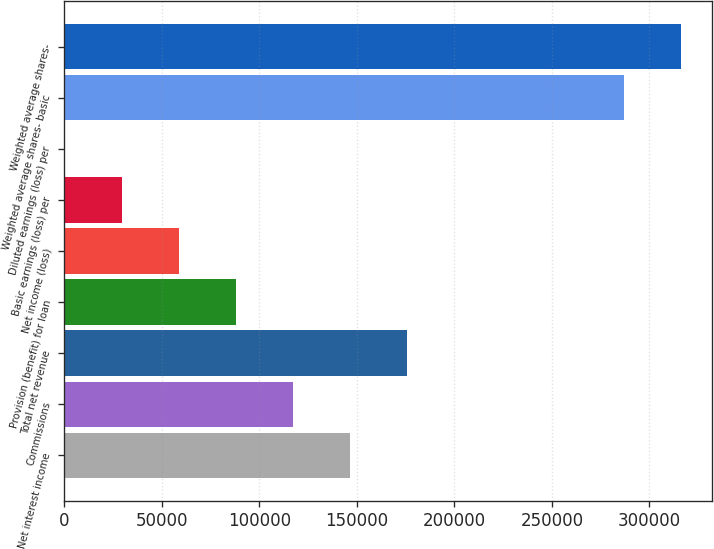Convert chart to OTSL. <chart><loc_0><loc_0><loc_500><loc_500><bar_chart><fcel>Net interest income<fcel>Commissions<fcel>Total net revenue<fcel>Provision (benefit) for loan<fcel>Net income (loss)<fcel>Basic earnings (loss) per<fcel>Diluted earnings (loss) per<fcel>Weighted average shares- basic<fcel>Weighted average shares-<nl><fcel>146295<fcel>117036<fcel>175554<fcel>87776.9<fcel>58518<fcel>29259.2<fcel>0.29<fcel>286991<fcel>316250<nl></chart> 